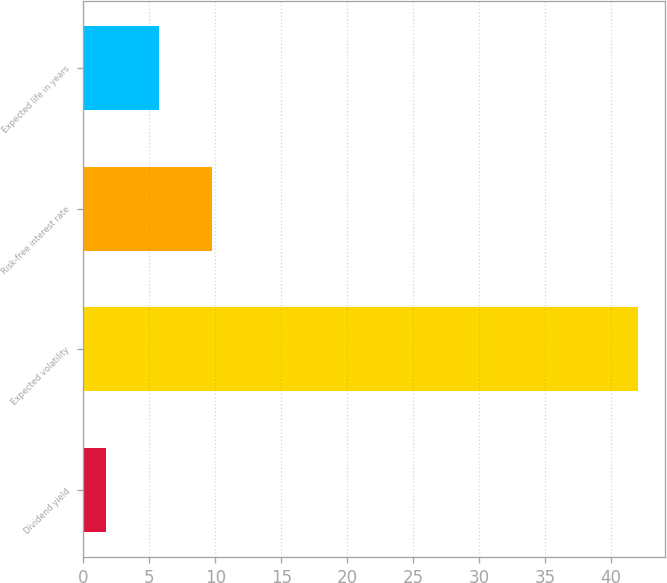Convert chart. <chart><loc_0><loc_0><loc_500><loc_500><bar_chart><fcel>Dividend yield<fcel>Expected volatility<fcel>Risk-free interest rate<fcel>Expected life in years<nl><fcel>1.7<fcel>42<fcel>9.76<fcel>5.73<nl></chart> 